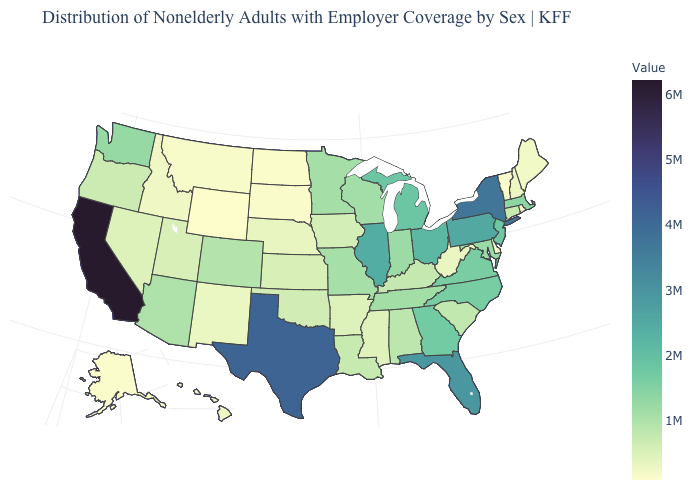Which states have the lowest value in the West?
Give a very brief answer. Wyoming. Which states have the lowest value in the USA?
Answer briefly. Wyoming. Does Illinois have the highest value in the MidWest?
Answer briefly. Yes. Which states have the lowest value in the USA?
Quick response, please. Wyoming. Among the states that border Arkansas , does Louisiana have the highest value?
Quick response, please. No. Which states have the highest value in the USA?
Give a very brief answer. California. 